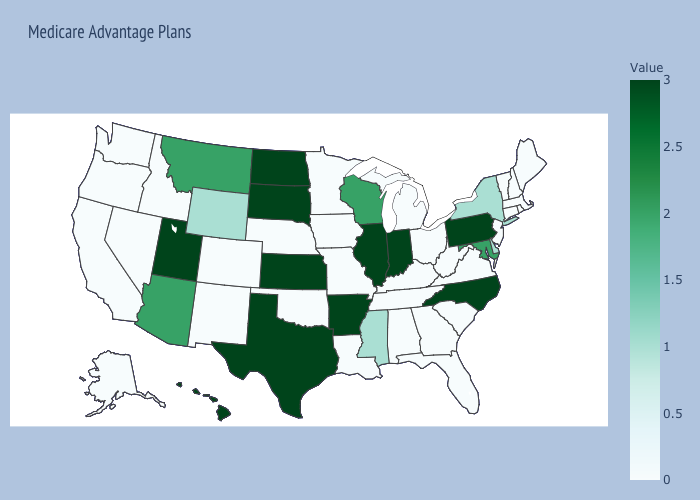Which states have the lowest value in the USA?
Concise answer only. Alabama, Alaska, California, Colorado, Connecticut, Florida, Georgia, Idaho, Iowa, Kentucky, Louisiana, Maine, Massachusetts, Michigan, Minnesota, Missouri, Nebraska, Nevada, New Hampshire, New Jersey, New Mexico, Ohio, Oklahoma, Oregon, Rhode Island, South Carolina, Tennessee, Vermont, Virginia, Washington, West Virginia. Which states have the lowest value in the USA?
Quick response, please. Alabama, Alaska, California, Colorado, Connecticut, Florida, Georgia, Idaho, Iowa, Kentucky, Louisiana, Maine, Massachusetts, Michigan, Minnesota, Missouri, Nebraska, Nevada, New Hampshire, New Jersey, New Mexico, Ohio, Oklahoma, Oregon, Rhode Island, South Carolina, Tennessee, Vermont, Virginia, Washington, West Virginia. Does Hawaii have a higher value than Florida?
Be succinct. Yes. Among the states that border Arkansas , does Tennessee have the lowest value?
Keep it brief. Yes. Which states hav the highest value in the MidWest?
Concise answer only. Illinois, Indiana, Kansas, North Dakota, South Dakota. 